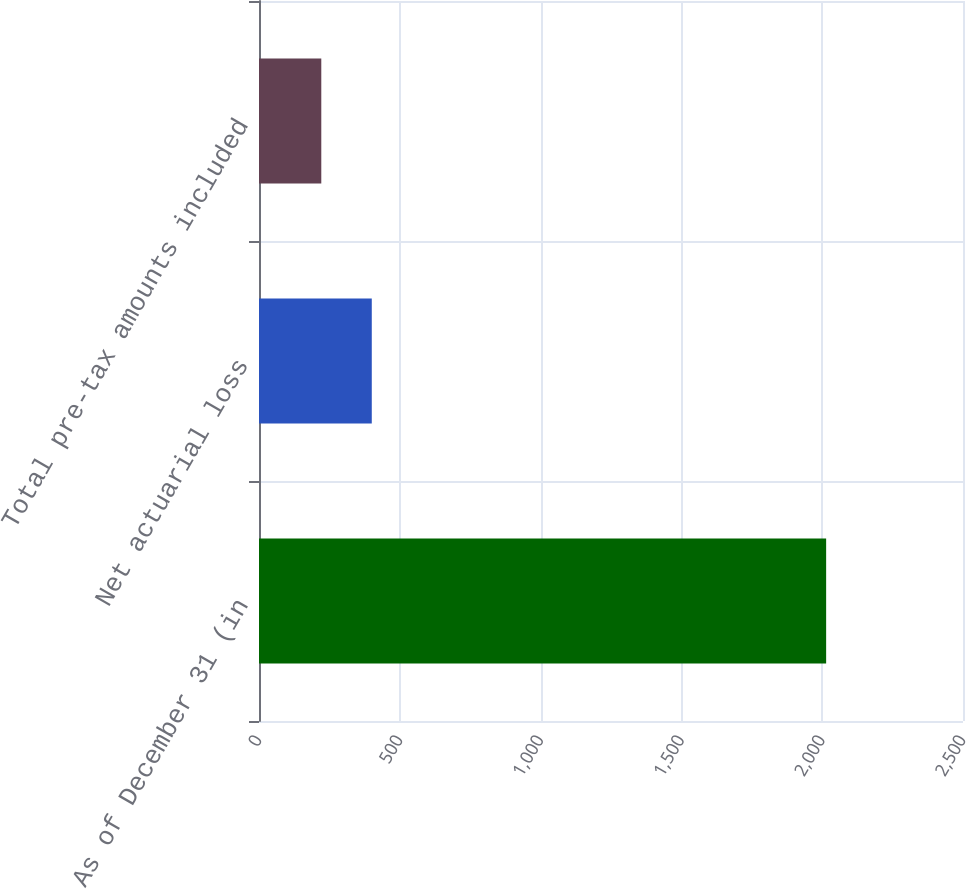<chart> <loc_0><loc_0><loc_500><loc_500><bar_chart><fcel>As of December 31 (in<fcel>Net actuarial loss<fcel>Total pre-tax amounts included<nl><fcel>2014<fcel>400.48<fcel>221.2<nl></chart> 